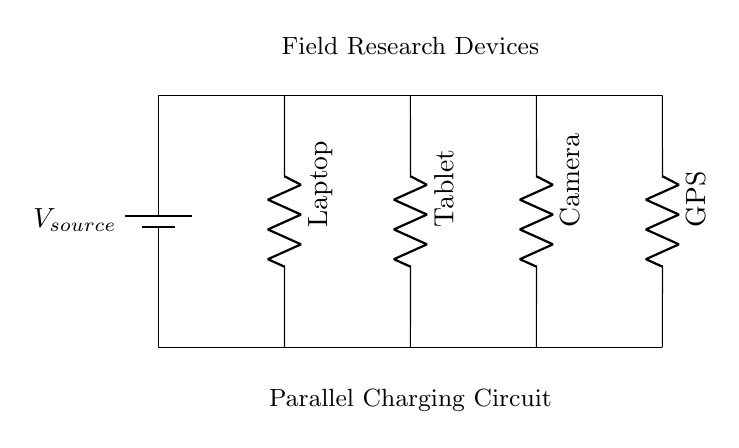What type of circuit is shown? The circuit diagram depicts a parallel circuit because all devices are connected to the same voltage source across individual branches, allowing each device to operate independently.
Answer: Parallel circuit What are the devices being charged? The devices connected in the circuit are a laptop, tablet, camera, and GPS, each represented by a resistor symbol in the circuit.
Answer: Laptop, tablet, camera, GPS What is the main advantage of using a parallel circuit for charging? The main advantage is that each device receives the same voltage from the source, allowing them to charge at their maximum efficiency without being affected by the other devices.
Answer: Equal voltage How many devices can this circuit charge? The circuit diagram shows four devices connected in parallel, indicating that it can charge four devices simultaneously.
Answer: Four If one device fails, what happens to the others? If one device fails in a parallel circuit, the other devices will continue to function normally because they are independently connected to the voltage source.
Answer: Others continue charging What is the significance of the battery in this circuit? The battery serves as the voltage source for the entire circuit, providing the necessary electrical energy for charging all connected devices simultaneously.
Answer: Voltage source What would happen if one of the resistance values changes? If one of the resistance values changes, the current through that branch will change according to Ohm's law, but the voltage across each device will remain the same due to the structure of a parallel circuit.
Answer: Current changes 